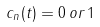Convert formula to latex. <formula><loc_0><loc_0><loc_500><loc_500>c _ { n } ( t ) = 0 \, o r \, 1</formula> 